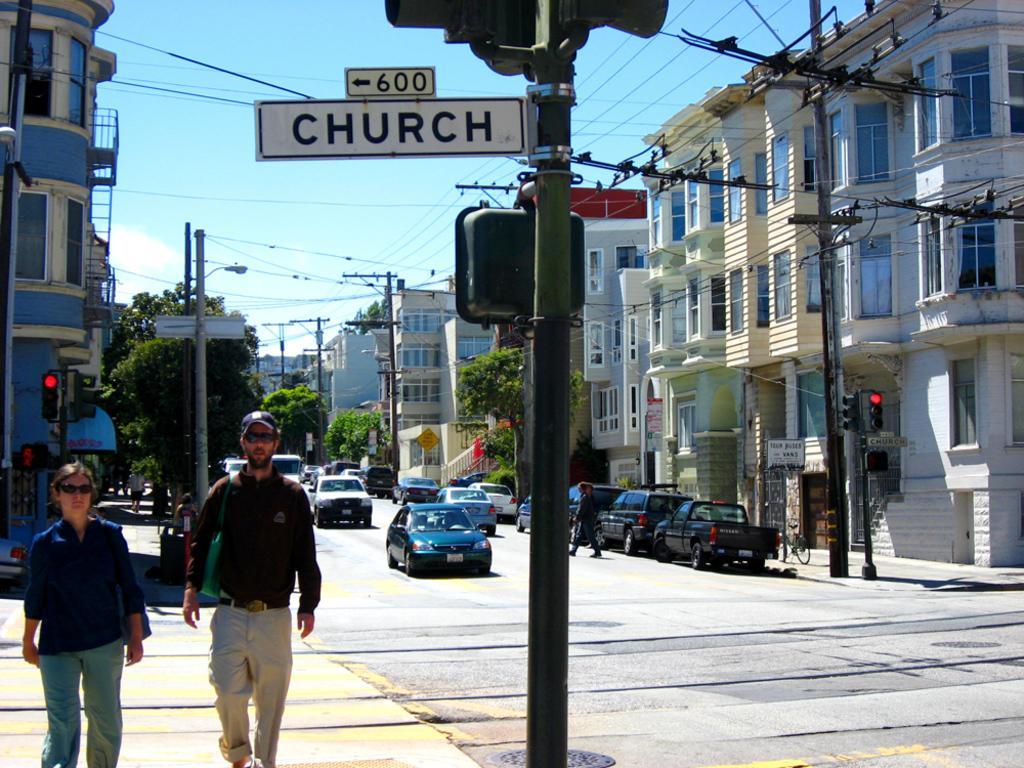Please provide a concise description of this image. This picture is clicked outside and we can see the group of people. In the center we can see the vehicles and we can see the poles, cables, birds and the lamp posts and the traffic lights and we can see the text and numbers on the boards. In the background we can see the sky, buildings, trees and many other objects. 